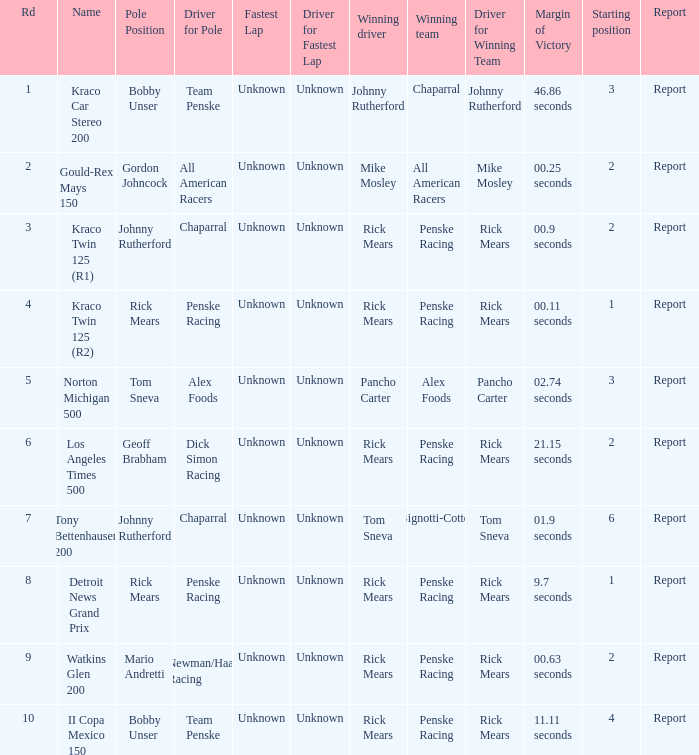What are the races that johnny rutherford has won? Kraco Car Stereo 200. 